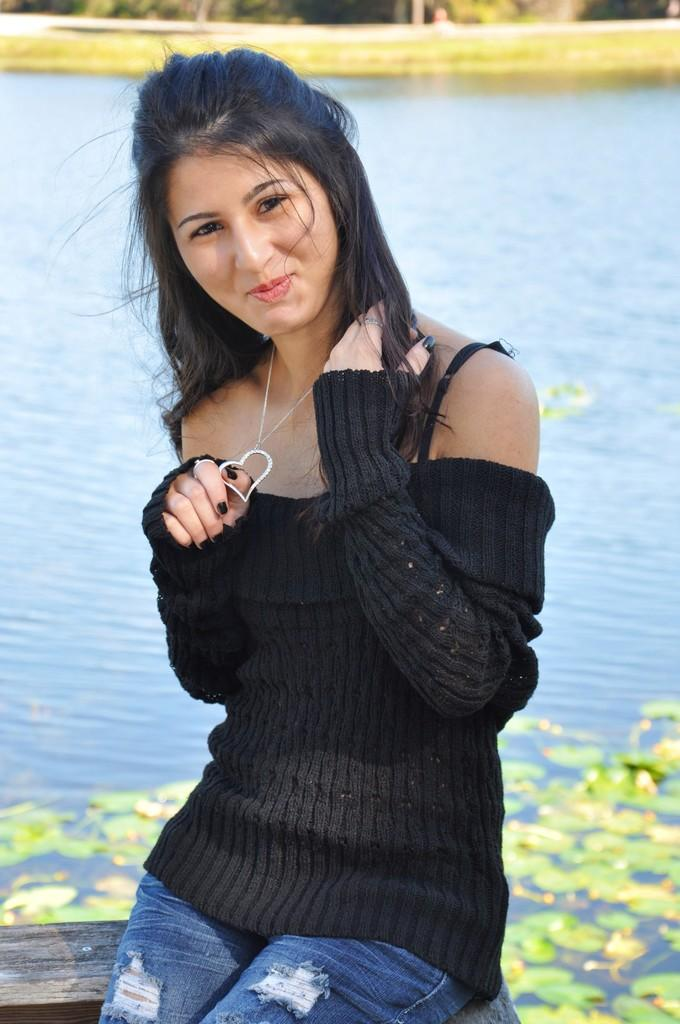What is the woman doing in the image? The woman is sitting at the water in the image. What can be seen in the background of the image? Water, grass, and trees are visible in the background of the image. What advice does the ornament in the image give to the woman? There is no ornament present in the image, so it cannot provide any advice to the woman. 